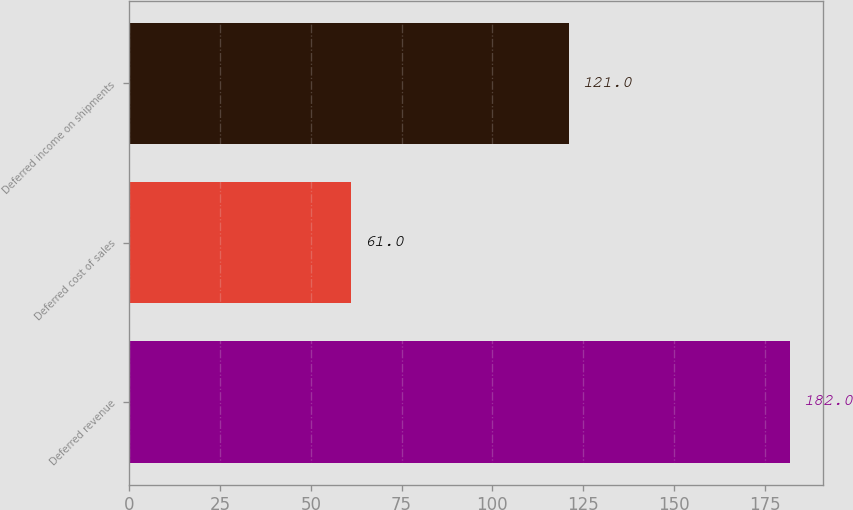Convert chart to OTSL. <chart><loc_0><loc_0><loc_500><loc_500><bar_chart><fcel>Deferred revenue<fcel>Deferred cost of sales<fcel>Deferred income on shipments<nl><fcel>182<fcel>61<fcel>121<nl></chart> 